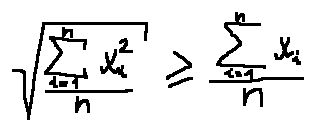Convert formula to latex. <formula><loc_0><loc_0><loc_500><loc_500>\sqrt { \frac { \sum \lim i t s _ { i = 1 } ^ { n } x _ { i } ^ { 2 } } { n } } \geq \frac { \sum \lim i t s _ { i = 1 } ^ { n } x _ { i } } { n }</formula> 